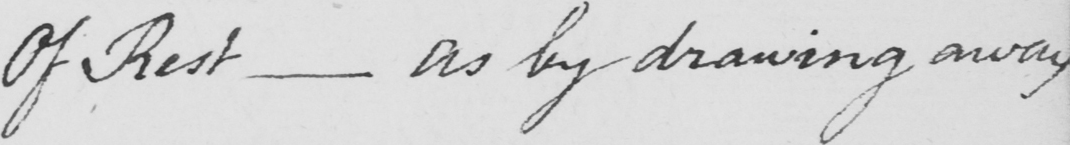What does this handwritten line say? Of Rest  _  as by drawing away 